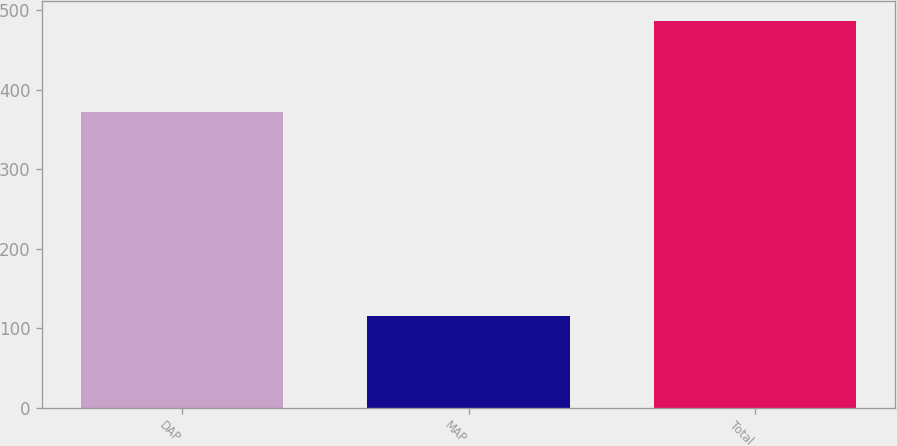Convert chart to OTSL. <chart><loc_0><loc_0><loc_500><loc_500><bar_chart><fcel>DAP<fcel>MAP<fcel>Total<nl><fcel>372<fcel>115<fcel>487<nl></chart> 